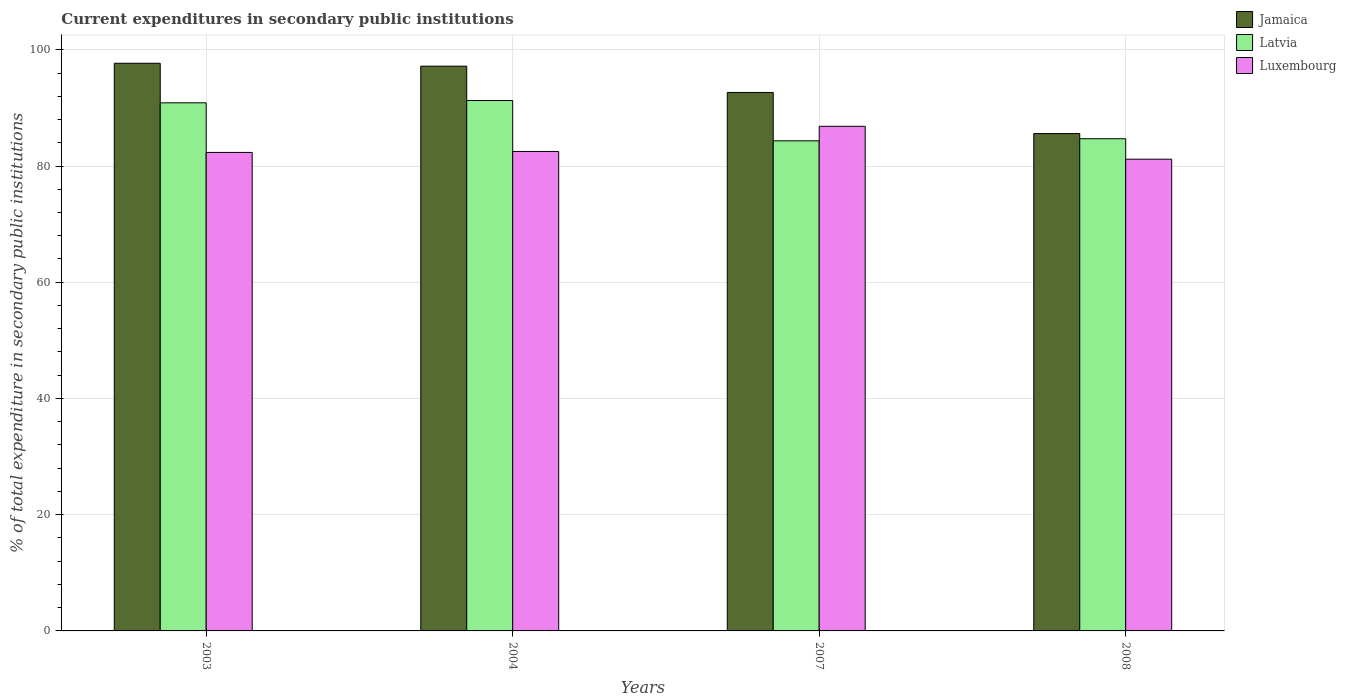How many groups of bars are there?
Offer a very short reply. 4. Are the number of bars per tick equal to the number of legend labels?
Your response must be concise. Yes. How many bars are there on the 4th tick from the right?
Your response must be concise. 3. What is the label of the 3rd group of bars from the left?
Make the answer very short. 2007. In how many cases, is the number of bars for a given year not equal to the number of legend labels?
Provide a succinct answer. 0. What is the current expenditures in secondary public institutions in Latvia in 2007?
Your answer should be compact. 84.33. Across all years, what is the maximum current expenditures in secondary public institutions in Latvia?
Make the answer very short. 91.27. Across all years, what is the minimum current expenditures in secondary public institutions in Jamaica?
Ensure brevity in your answer.  85.58. In which year was the current expenditures in secondary public institutions in Jamaica maximum?
Give a very brief answer. 2003. In which year was the current expenditures in secondary public institutions in Luxembourg minimum?
Your answer should be compact. 2008. What is the total current expenditures in secondary public institutions in Latvia in the graph?
Offer a terse response. 351.17. What is the difference between the current expenditures in secondary public institutions in Latvia in 2004 and that in 2008?
Your response must be concise. 6.58. What is the difference between the current expenditures in secondary public institutions in Luxembourg in 2003 and the current expenditures in secondary public institutions in Latvia in 2004?
Offer a very short reply. -8.93. What is the average current expenditures in secondary public institutions in Jamaica per year?
Provide a short and direct response. 93.28. In the year 2003, what is the difference between the current expenditures in secondary public institutions in Jamaica and current expenditures in secondary public institutions in Luxembourg?
Provide a short and direct response. 15.34. What is the ratio of the current expenditures in secondary public institutions in Latvia in 2003 to that in 2004?
Your answer should be very brief. 1. What is the difference between the highest and the second highest current expenditures in secondary public institutions in Luxembourg?
Your response must be concise. 4.33. What is the difference between the highest and the lowest current expenditures in secondary public institutions in Jamaica?
Your response must be concise. 12.1. Is the sum of the current expenditures in secondary public institutions in Luxembourg in 2007 and 2008 greater than the maximum current expenditures in secondary public institutions in Jamaica across all years?
Your response must be concise. Yes. What does the 1st bar from the left in 2003 represents?
Offer a terse response. Jamaica. What does the 1st bar from the right in 2008 represents?
Your response must be concise. Luxembourg. How many years are there in the graph?
Your response must be concise. 4. Are the values on the major ticks of Y-axis written in scientific E-notation?
Offer a terse response. No. Does the graph contain any zero values?
Provide a short and direct response. No. Does the graph contain grids?
Keep it short and to the point. Yes. How are the legend labels stacked?
Your response must be concise. Vertical. What is the title of the graph?
Provide a short and direct response. Current expenditures in secondary public institutions. What is the label or title of the X-axis?
Give a very brief answer. Years. What is the label or title of the Y-axis?
Your answer should be very brief. % of total expenditure in secondary public institutions. What is the % of total expenditure in secondary public institutions in Jamaica in 2003?
Keep it short and to the point. 97.68. What is the % of total expenditure in secondary public institutions in Latvia in 2003?
Provide a short and direct response. 90.87. What is the % of total expenditure in secondary public institutions in Luxembourg in 2003?
Your answer should be compact. 82.34. What is the % of total expenditure in secondary public institutions of Jamaica in 2004?
Offer a terse response. 97.18. What is the % of total expenditure in secondary public institutions of Latvia in 2004?
Keep it short and to the point. 91.27. What is the % of total expenditure in secondary public institutions of Luxembourg in 2004?
Make the answer very short. 82.5. What is the % of total expenditure in secondary public institutions of Jamaica in 2007?
Your answer should be very brief. 92.66. What is the % of total expenditure in secondary public institutions of Latvia in 2007?
Offer a terse response. 84.33. What is the % of total expenditure in secondary public institutions of Luxembourg in 2007?
Give a very brief answer. 86.83. What is the % of total expenditure in secondary public institutions of Jamaica in 2008?
Your answer should be very brief. 85.58. What is the % of total expenditure in secondary public institutions in Latvia in 2008?
Provide a short and direct response. 84.69. What is the % of total expenditure in secondary public institutions of Luxembourg in 2008?
Provide a succinct answer. 81.17. Across all years, what is the maximum % of total expenditure in secondary public institutions in Jamaica?
Your answer should be very brief. 97.68. Across all years, what is the maximum % of total expenditure in secondary public institutions of Latvia?
Provide a short and direct response. 91.27. Across all years, what is the maximum % of total expenditure in secondary public institutions of Luxembourg?
Ensure brevity in your answer.  86.83. Across all years, what is the minimum % of total expenditure in secondary public institutions of Jamaica?
Offer a very short reply. 85.58. Across all years, what is the minimum % of total expenditure in secondary public institutions of Latvia?
Give a very brief answer. 84.33. Across all years, what is the minimum % of total expenditure in secondary public institutions of Luxembourg?
Give a very brief answer. 81.17. What is the total % of total expenditure in secondary public institutions in Jamaica in the graph?
Offer a very short reply. 373.1. What is the total % of total expenditure in secondary public institutions of Latvia in the graph?
Provide a short and direct response. 351.17. What is the total % of total expenditure in secondary public institutions of Luxembourg in the graph?
Your answer should be very brief. 332.83. What is the difference between the % of total expenditure in secondary public institutions of Jamaica in 2003 and that in 2004?
Your answer should be compact. 0.5. What is the difference between the % of total expenditure in secondary public institutions in Latvia in 2003 and that in 2004?
Give a very brief answer. -0.4. What is the difference between the % of total expenditure in secondary public institutions in Luxembourg in 2003 and that in 2004?
Your answer should be very brief. -0.16. What is the difference between the % of total expenditure in secondary public institutions in Jamaica in 2003 and that in 2007?
Your response must be concise. 5.02. What is the difference between the % of total expenditure in secondary public institutions of Latvia in 2003 and that in 2007?
Provide a short and direct response. 6.54. What is the difference between the % of total expenditure in secondary public institutions in Luxembourg in 2003 and that in 2007?
Your response must be concise. -4.49. What is the difference between the % of total expenditure in secondary public institutions of Jamaica in 2003 and that in 2008?
Your response must be concise. 12.1. What is the difference between the % of total expenditure in secondary public institutions of Latvia in 2003 and that in 2008?
Provide a succinct answer. 6.18. What is the difference between the % of total expenditure in secondary public institutions of Luxembourg in 2003 and that in 2008?
Your answer should be very brief. 1.17. What is the difference between the % of total expenditure in secondary public institutions in Jamaica in 2004 and that in 2007?
Your answer should be very brief. 4.52. What is the difference between the % of total expenditure in secondary public institutions in Latvia in 2004 and that in 2007?
Keep it short and to the point. 6.94. What is the difference between the % of total expenditure in secondary public institutions in Luxembourg in 2004 and that in 2007?
Your answer should be compact. -4.33. What is the difference between the % of total expenditure in secondary public institutions of Jamaica in 2004 and that in 2008?
Offer a terse response. 11.6. What is the difference between the % of total expenditure in secondary public institutions in Latvia in 2004 and that in 2008?
Keep it short and to the point. 6.58. What is the difference between the % of total expenditure in secondary public institutions of Luxembourg in 2004 and that in 2008?
Offer a terse response. 1.33. What is the difference between the % of total expenditure in secondary public institutions in Jamaica in 2007 and that in 2008?
Keep it short and to the point. 7.07. What is the difference between the % of total expenditure in secondary public institutions of Latvia in 2007 and that in 2008?
Make the answer very short. -0.36. What is the difference between the % of total expenditure in secondary public institutions of Luxembourg in 2007 and that in 2008?
Offer a terse response. 5.66. What is the difference between the % of total expenditure in secondary public institutions in Jamaica in 2003 and the % of total expenditure in secondary public institutions in Latvia in 2004?
Ensure brevity in your answer.  6.41. What is the difference between the % of total expenditure in secondary public institutions in Jamaica in 2003 and the % of total expenditure in secondary public institutions in Luxembourg in 2004?
Your answer should be compact. 15.18. What is the difference between the % of total expenditure in secondary public institutions of Latvia in 2003 and the % of total expenditure in secondary public institutions of Luxembourg in 2004?
Make the answer very short. 8.37. What is the difference between the % of total expenditure in secondary public institutions of Jamaica in 2003 and the % of total expenditure in secondary public institutions of Latvia in 2007?
Your response must be concise. 13.35. What is the difference between the % of total expenditure in secondary public institutions of Jamaica in 2003 and the % of total expenditure in secondary public institutions of Luxembourg in 2007?
Keep it short and to the point. 10.85. What is the difference between the % of total expenditure in secondary public institutions in Latvia in 2003 and the % of total expenditure in secondary public institutions in Luxembourg in 2007?
Make the answer very short. 4.04. What is the difference between the % of total expenditure in secondary public institutions of Jamaica in 2003 and the % of total expenditure in secondary public institutions of Latvia in 2008?
Your answer should be very brief. 12.99. What is the difference between the % of total expenditure in secondary public institutions in Jamaica in 2003 and the % of total expenditure in secondary public institutions in Luxembourg in 2008?
Keep it short and to the point. 16.51. What is the difference between the % of total expenditure in secondary public institutions in Latvia in 2003 and the % of total expenditure in secondary public institutions in Luxembourg in 2008?
Give a very brief answer. 9.7. What is the difference between the % of total expenditure in secondary public institutions of Jamaica in 2004 and the % of total expenditure in secondary public institutions of Latvia in 2007?
Offer a terse response. 12.85. What is the difference between the % of total expenditure in secondary public institutions of Jamaica in 2004 and the % of total expenditure in secondary public institutions of Luxembourg in 2007?
Provide a succinct answer. 10.35. What is the difference between the % of total expenditure in secondary public institutions in Latvia in 2004 and the % of total expenditure in secondary public institutions in Luxembourg in 2007?
Your answer should be compact. 4.44. What is the difference between the % of total expenditure in secondary public institutions of Jamaica in 2004 and the % of total expenditure in secondary public institutions of Latvia in 2008?
Your answer should be very brief. 12.49. What is the difference between the % of total expenditure in secondary public institutions in Jamaica in 2004 and the % of total expenditure in secondary public institutions in Luxembourg in 2008?
Give a very brief answer. 16.01. What is the difference between the % of total expenditure in secondary public institutions of Latvia in 2004 and the % of total expenditure in secondary public institutions of Luxembourg in 2008?
Ensure brevity in your answer.  10.1. What is the difference between the % of total expenditure in secondary public institutions of Jamaica in 2007 and the % of total expenditure in secondary public institutions of Latvia in 2008?
Your response must be concise. 7.96. What is the difference between the % of total expenditure in secondary public institutions of Jamaica in 2007 and the % of total expenditure in secondary public institutions of Luxembourg in 2008?
Make the answer very short. 11.49. What is the difference between the % of total expenditure in secondary public institutions in Latvia in 2007 and the % of total expenditure in secondary public institutions in Luxembourg in 2008?
Your answer should be compact. 3.16. What is the average % of total expenditure in secondary public institutions of Jamaica per year?
Offer a very short reply. 93.28. What is the average % of total expenditure in secondary public institutions in Latvia per year?
Provide a succinct answer. 87.79. What is the average % of total expenditure in secondary public institutions in Luxembourg per year?
Give a very brief answer. 83.21. In the year 2003, what is the difference between the % of total expenditure in secondary public institutions in Jamaica and % of total expenditure in secondary public institutions in Latvia?
Ensure brevity in your answer.  6.81. In the year 2003, what is the difference between the % of total expenditure in secondary public institutions of Jamaica and % of total expenditure in secondary public institutions of Luxembourg?
Your answer should be very brief. 15.34. In the year 2003, what is the difference between the % of total expenditure in secondary public institutions in Latvia and % of total expenditure in secondary public institutions in Luxembourg?
Offer a terse response. 8.54. In the year 2004, what is the difference between the % of total expenditure in secondary public institutions of Jamaica and % of total expenditure in secondary public institutions of Latvia?
Keep it short and to the point. 5.91. In the year 2004, what is the difference between the % of total expenditure in secondary public institutions of Jamaica and % of total expenditure in secondary public institutions of Luxembourg?
Offer a terse response. 14.68. In the year 2004, what is the difference between the % of total expenditure in secondary public institutions of Latvia and % of total expenditure in secondary public institutions of Luxembourg?
Keep it short and to the point. 8.77. In the year 2007, what is the difference between the % of total expenditure in secondary public institutions of Jamaica and % of total expenditure in secondary public institutions of Latvia?
Provide a succinct answer. 8.33. In the year 2007, what is the difference between the % of total expenditure in secondary public institutions of Jamaica and % of total expenditure in secondary public institutions of Luxembourg?
Provide a short and direct response. 5.83. In the year 2007, what is the difference between the % of total expenditure in secondary public institutions of Latvia and % of total expenditure in secondary public institutions of Luxembourg?
Keep it short and to the point. -2.5. In the year 2008, what is the difference between the % of total expenditure in secondary public institutions of Jamaica and % of total expenditure in secondary public institutions of Latvia?
Give a very brief answer. 0.89. In the year 2008, what is the difference between the % of total expenditure in secondary public institutions in Jamaica and % of total expenditure in secondary public institutions in Luxembourg?
Your response must be concise. 4.41. In the year 2008, what is the difference between the % of total expenditure in secondary public institutions of Latvia and % of total expenditure in secondary public institutions of Luxembourg?
Offer a very short reply. 3.52. What is the ratio of the % of total expenditure in secondary public institutions of Jamaica in 2003 to that in 2004?
Keep it short and to the point. 1.01. What is the ratio of the % of total expenditure in secondary public institutions in Luxembourg in 2003 to that in 2004?
Your answer should be compact. 1. What is the ratio of the % of total expenditure in secondary public institutions in Jamaica in 2003 to that in 2007?
Ensure brevity in your answer.  1.05. What is the ratio of the % of total expenditure in secondary public institutions of Latvia in 2003 to that in 2007?
Your answer should be compact. 1.08. What is the ratio of the % of total expenditure in secondary public institutions of Luxembourg in 2003 to that in 2007?
Provide a short and direct response. 0.95. What is the ratio of the % of total expenditure in secondary public institutions in Jamaica in 2003 to that in 2008?
Give a very brief answer. 1.14. What is the ratio of the % of total expenditure in secondary public institutions of Latvia in 2003 to that in 2008?
Offer a terse response. 1.07. What is the ratio of the % of total expenditure in secondary public institutions in Luxembourg in 2003 to that in 2008?
Ensure brevity in your answer.  1.01. What is the ratio of the % of total expenditure in secondary public institutions in Jamaica in 2004 to that in 2007?
Offer a terse response. 1.05. What is the ratio of the % of total expenditure in secondary public institutions in Latvia in 2004 to that in 2007?
Your response must be concise. 1.08. What is the ratio of the % of total expenditure in secondary public institutions in Luxembourg in 2004 to that in 2007?
Provide a succinct answer. 0.95. What is the ratio of the % of total expenditure in secondary public institutions in Jamaica in 2004 to that in 2008?
Your answer should be compact. 1.14. What is the ratio of the % of total expenditure in secondary public institutions in Latvia in 2004 to that in 2008?
Provide a short and direct response. 1.08. What is the ratio of the % of total expenditure in secondary public institutions in Luxembourg in 2004 to that in 2008?
Provide a short and direct response. 1.02. What is the ratio of the % of total expenditure in secondary public institutions of Jamaica in 2007 to that in 2008?
Your answer should be compact. 1.08. What is the ratio of the % of total expenditure in secondary public institutions of Latvia in 2007 to that in 2008?
Your answer should be compact. 1. What is the ratio of the % of total expenditure in secondary public institutions of Luxembourg in 2007 to that in 2008?
Ensure brevity in your answer.  1.07. What is the difference between the highest and the second highest % of total expenditure in secondary public institutions of Jamaica?
Offer a terse response. 0.5. What is the difference between the highest and the second highest % of total expenditure in secondary public institutions of Latvia?
Make the answer very short. 0.4. What is the difference between the highest and the second highest % of total expenditure in secondary public institutions in Luxembourg?
Offer a terse response. 4.33. What is the difference between the highest and the lowest % of total expenditure in secondary public institutions of Jamaica?
Give a very brief answer. 12.1. What is the difference between the highest and the lowest % of total expenditure in secondary public institutions of Latvia?
Your answer should be very brief. 6.94. What is the difference between the highest and the lowest % of total expenditure in secondary public institutions of Luxembourg?
Provide a short and direct response. 5.66. 